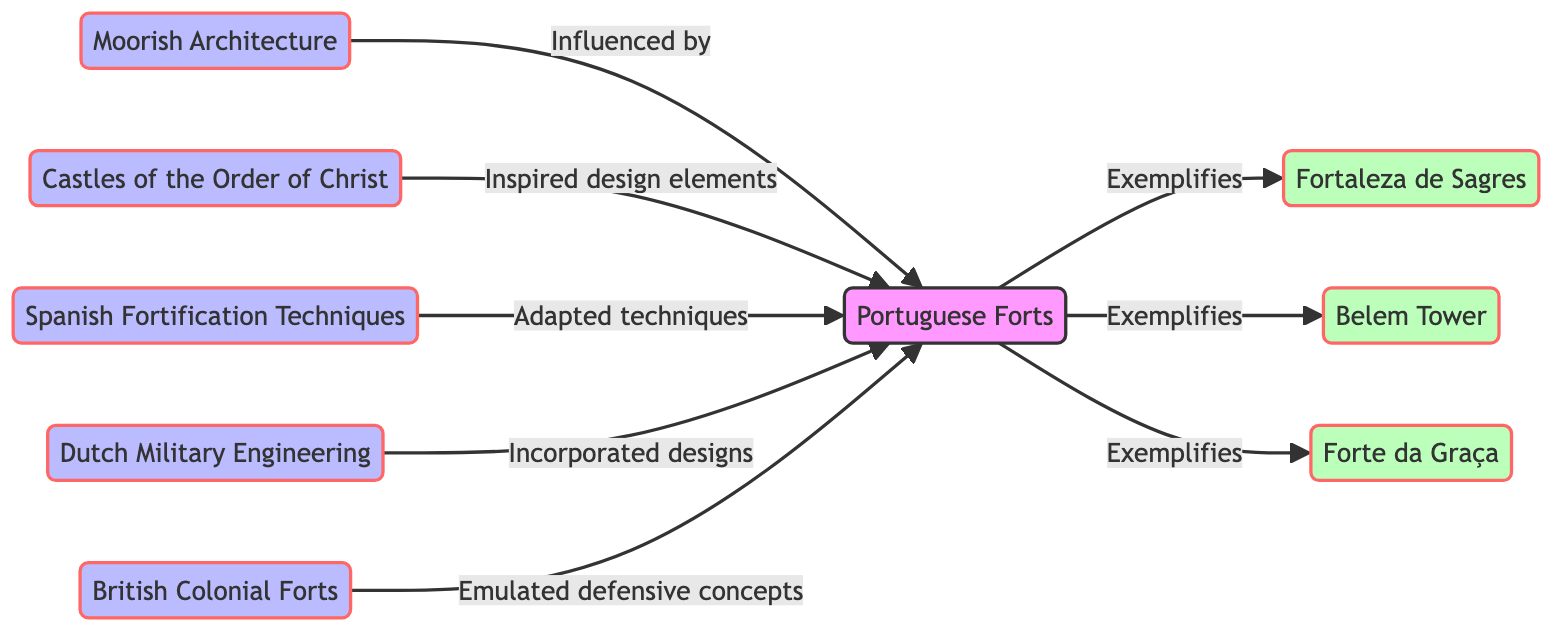What is the total number of nodes in the diagram? Counting the nodes listed in the diagram, there are eight distinct entities: Portuguese Forts, Moorish Architecture, Castles of the Order of Christ, Spanish Fortification Techniques, Dutch Military Engineering, British Colonial Forts, Fortaleza de Sagres, Belem Tower, and Forte da Graça. Therefore, the total number of nodes is eight.
Answer: 8 Which architecture directly influences Portuguese Forts? The edge indicating influence points directly from Moorish Architecture to Portuguese Forts, denoting that it is a significant source of influence on fort design in Portugal.
Answer: Moorish Architecture How many examples of Portuguese Forts are shown in the diagram? The diagram lists three specific examples of Portuguese Forts labeled as Fortaleza de Sagres, Belem Tower, and Forte da Graça, linked by the "Exemplifies" relationship to Portuguese Forts.
Answer: 3 Which military engineering style incorporated designs into Portuguese Forts? The directed edge from Dutch Military Engineering to Portuguese Forts indicates that this style played a role in the incorporation of designs specific to Portuguese Fort architecture.
Answer: Dutch Military Engineering What military concept do British Colonial Forts emulate? The directed connection from British Colonial Forts to Portuguese Forts specifies that they emulate defensive concepts, highlighting the influence of British designs on Portuguese fortifications.
Answer: Defensive concepts Which fort serves as an example of Portuguese Fort architecture? The term 'Exemplifies' links Portuguese Forts to multiple specific examples, one being Fortaleza de Sagres, which clearly demonstrates the architectural traits of the broader category.
Answer: Fortaleza de Sagres How does the Order of Christ relate to Portuguese Forts? The relationship depicted as "Inspired design elements" from Castles of the Order of Christ to Portuguese Forts indicates that this Order contributed certain design characteristics to Portuguese fortresses.
Answer: Inspired design elements What type of techniques were adapted from Spanish fortification? The connection labeled "Adapted techniques" from Spanish Fortification Techniques to Portuguese Forts signifies that Portuguese architecture utilized these particular methods for strengthening their fortifications.
Answer: Adapted techniques 